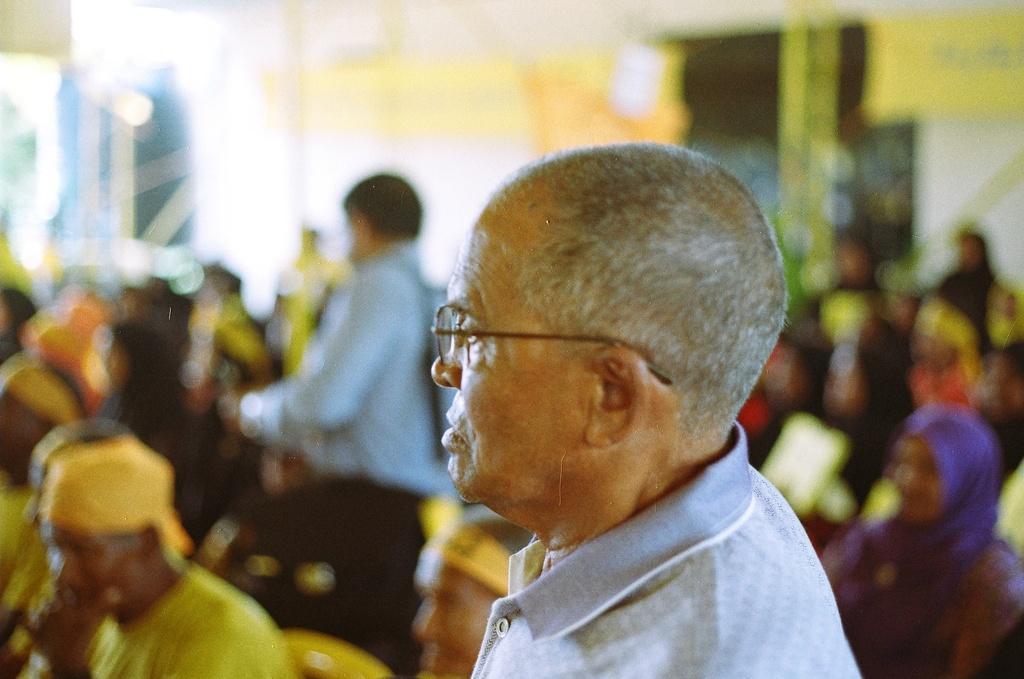How would you summarize this image in a sentence or two? In this image we can see a person wearing spectacles. On the backside we can see a group of people sitting. In that a man is standing. 